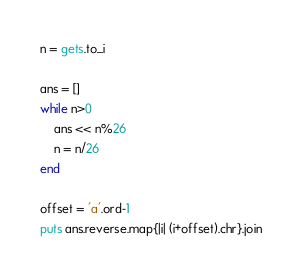<code> <loc_0><loc_0><loc_500><loc_500><_Ruby_>n = gets.to_i

ans = []
while n>0
    ans << n%26
    n = n/26
end

offset = 'a'.ord-1
puts ans.reverse.map{|i| (i+offset).chr}.join</code> 